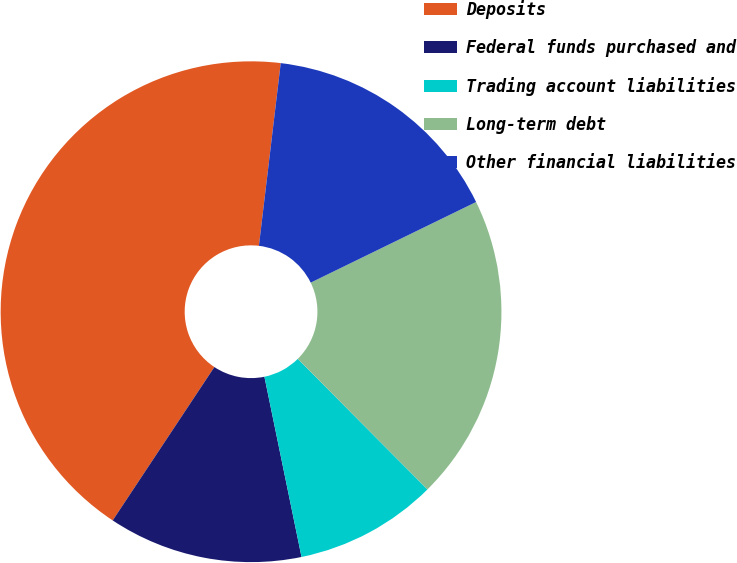<chart> <loc_0><loc_0><loc_500><loc_500><pie_chart><fcel>Deposits<fcel>Federal funds purchased and<fcel>Trading account liabilities<fcel>Long-term debt<fcel>Other financial liabilities<nl><fcel>42.58%<fcel>12.55%<fcel>9.21%<fcel>19.78%<fcel>15.89%<nl></chart> 